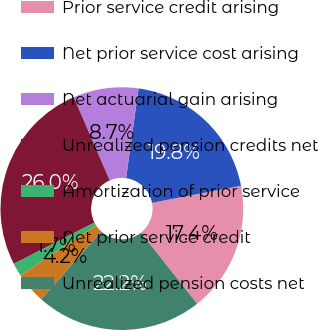<chart> <loc_0><loc_0><loc_500><loc_500><pie_chart><fcel>Prior service credit arising<fcel>Net prior service cost arising<fcel>Net actuarial gain arising<fcel>Unrealized pension credits net<fcel>Amortization of prior service<fcel>Net prior service credit<fcel>Unrealized pension costs net<nl><fcel>17.36%<fcel>19.79%<fcel>8.68%<fcel>26.04%<fcel>1.74%<fcel>4.17%<fcel>22.22%<nl></chart> 